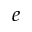Convert formula to latex. <formula><loc_0><loc_0><loc_500><loc_500>e</formula> 